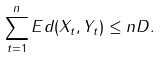Convert formula to latex. <formula><loc_0><loc_0><loc_500><loc_500>\sum _ { t = 1 } ^ { n } E d ( X _ { t } , Y _ { t } ) \leq n D .</formula> 